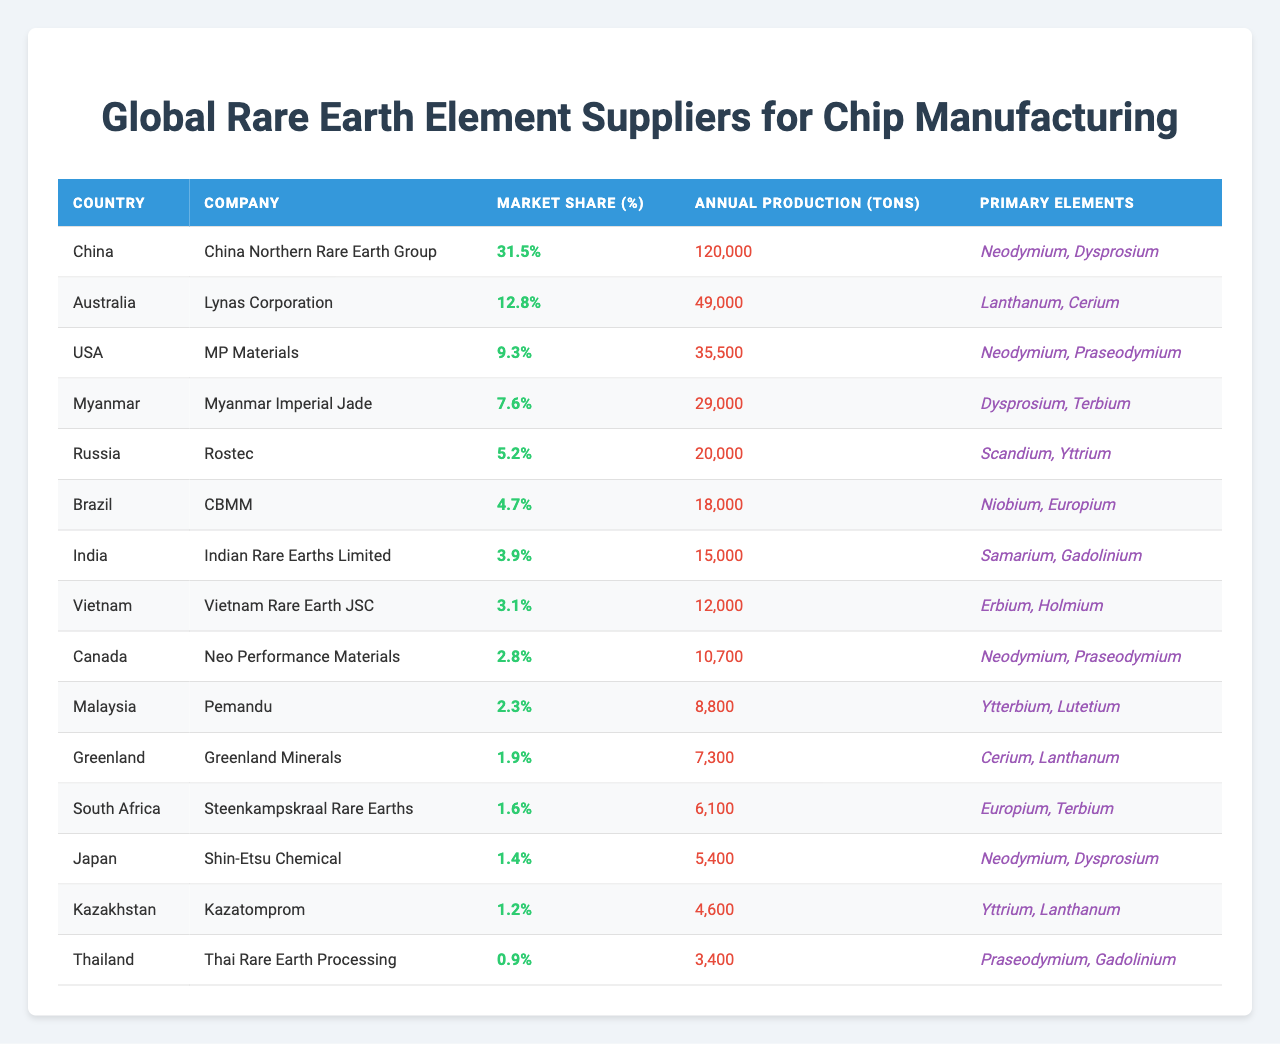What country has the highest market share in rare earth element supply for chip manufacturing? By looking at the 'Market Share (%)' column, we find that China has the highest percentage at 31.5%.
Answer: China What company produces the most annual tons of rare earth elements? The 'Annual Production (tons)' column shows China Northern Rare Earth Group produces 120,000 tons, which is the highest in the table.
Answer: China Northern Rare Earth Group What is the market share of MP Materials? The 'Market Share (%)' column indicates that MP Materials has a market share of 9.3%.
Answer: 9.3% Which country has the lowest market share among the listed suppliers? Scanning the 'Market Share (%)' column, Thailand has the lowest market share at 0.9%.
Answer: Thailand What is the average annual production of rare earth elements among the suppliers? The annual production figures are: 120000, 49000, 35500, 29000, 20000, 18000, 15000, 12000, 10700, 8800, 7300, 6100, 5400, 4600, 3400. The total production is 238,000 tons and there are 15 suppliers, so the average is 238,000 / 15 = 15,866.67 tons.
Answer: 15,866.67 tons Is there any company from Japan included in the table? Yes, based on the 'Country' column, there is a company listed from Japan, which is Shin-Etsu Chemical.
Answer: Yes What is the total market share of the top three companies? The top three companies are China Northern Rare Earth Group (31.5%), Lynas Corporation (12.8%), and MP Materials (9.3%). Summing these gives us 31.5 + 12.8 + 9.3 = 53.6%.
Answer: 53.6% Do any companies produce rare earth elements that include Samarium? Yes, Indian Rare Earths Limited from India produces elements that include Samarium, as stated in the 'Primary Elements' column.
Answer: Yes Which country produces more than 20,000 tons annually? Referring to the 'Annual Production (tons)' column, China, Australia, USA, Myanmar, and Russia produce more than 20,000 tons annually.
Answer: China, Australia, USA, Myanmar, Russia Which company has a primary element of Europium? According to the 'Primary Elements' column, CBMM from Brazil and Steenkampskraal Rare Earths from South Africa both list Europium.
Answer: CBMM, Steenkampskraal Rare Earths 